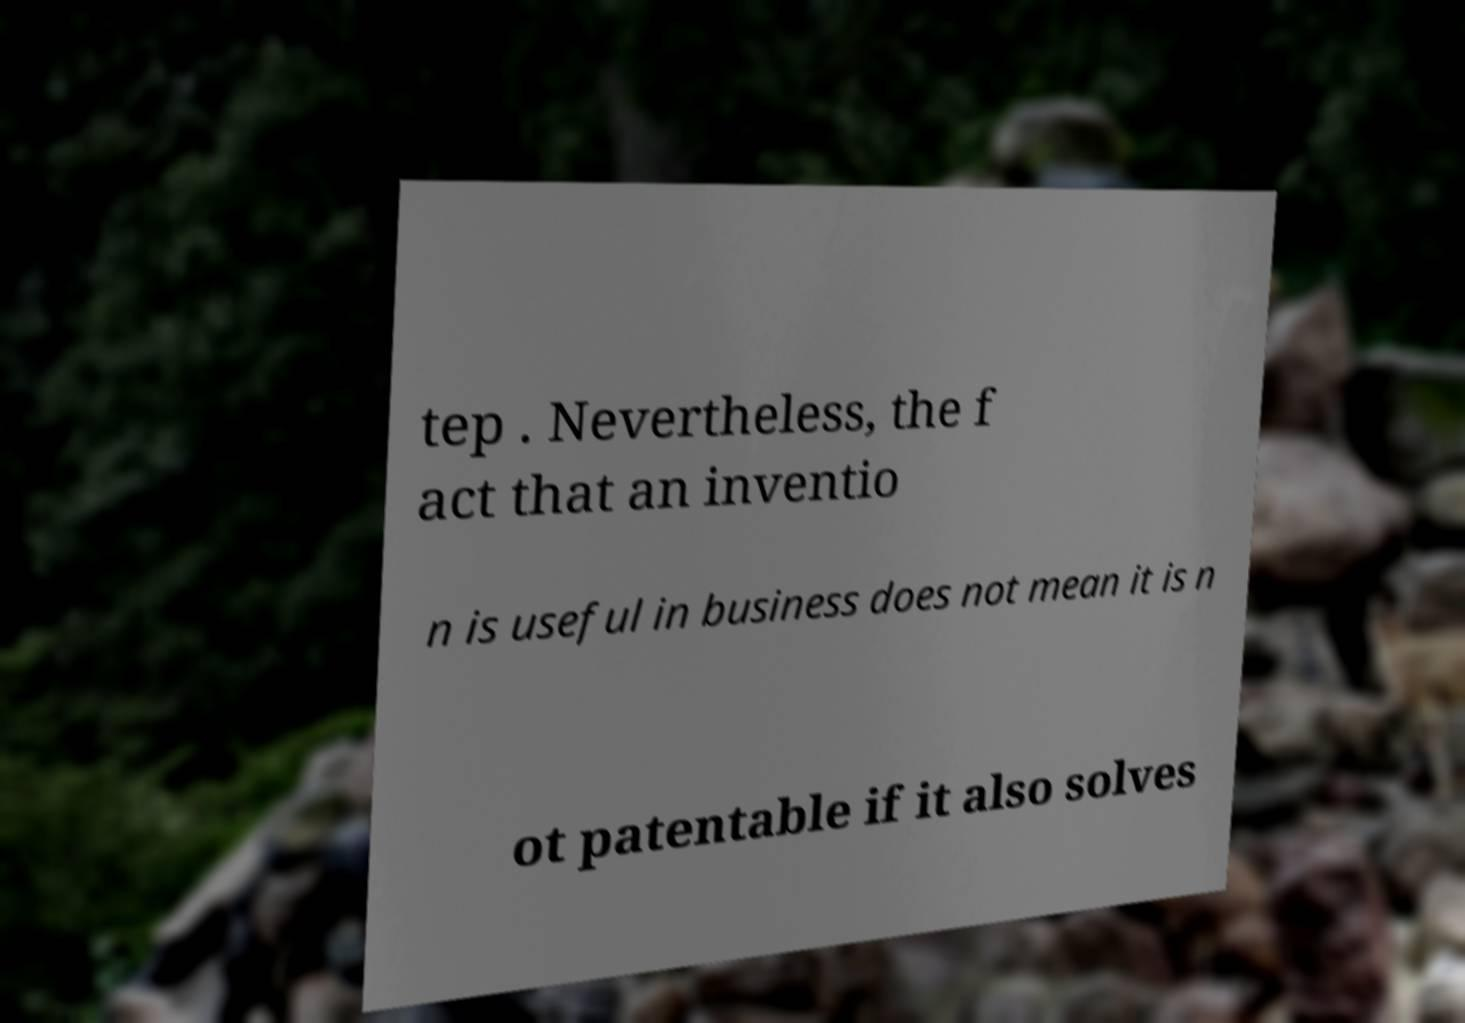Can you read and provide the text displayed in the image?This photo seems to have some interesting text. Can you extract and type it out for me? tep . Nevertheless, the f act that an inventio n is useful in business does not mean it is n ot patentable if it also solves 